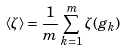Convert formula to latex. <formula><loc_0><loc_0><loc_500><loc_500>\langle \zeta \rangle = \frac { 1 } { m } \sum _ { k = 1 } ^ { m } \zeta ( g _ { k } )</formula> 